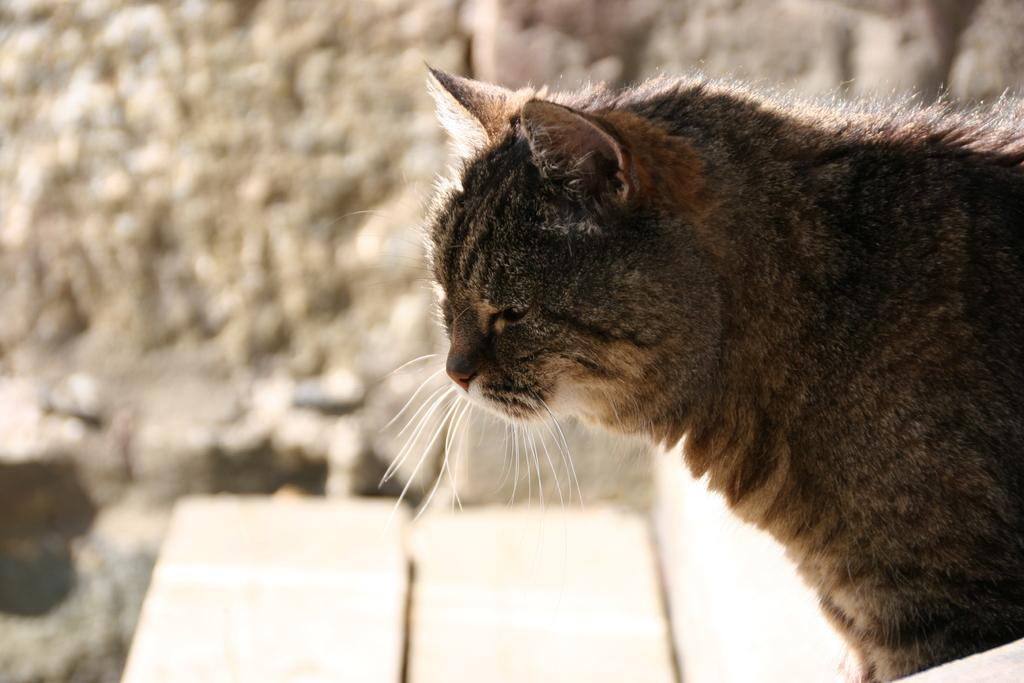What type of animal is in the image? There is a cat in the image. What can be seen behind the cat? There is a wall in the background of the image. What else is visible in the background of the image? There are objects visible in the background of the image. What type of hate can be seen on the cat's face in the image? There is no hate visible on the cat's face in the image; the cat appears to be relaxed or neutral. 